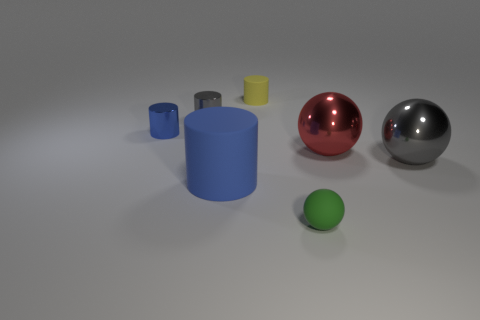Subtract all purple balls. Subtract all gray cylinders. How many balls are left? 3 Add 2 small yellow matte things. How many objects exist? 9 Subtract all spheres. How many objects are left? 4 Add 1 small brown cylinders. How many small brown cylinders exist? 1 Subtract 0 blue spheres. How many objects are left? 7 Subtract all tiny gray metal spheres. Subtract all big gray metal things. How many objects are left? 6 Add 7 big gray metal spheres. How many big gray metal spheres are left? 8 